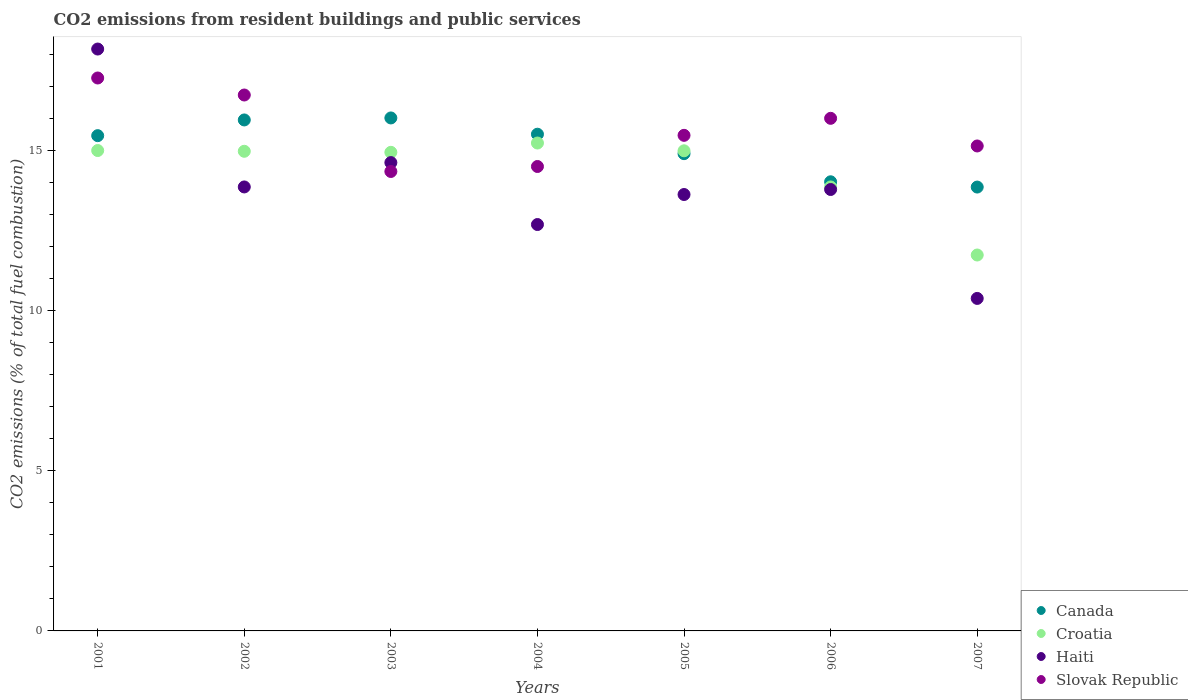Is the number of dotlines equal to the number of legend labels?
Your response must be concise. Yes. What is the total CO2 emitted in Canada in 2001?
Your answer should be very brief. 15.48. Across all years, what is the maximum total CO2 emitted in Slovak Republic?
Give a very brief answer. 17.28. Across all years, what is the minimum total CO2 emitted in Canada?
Your response must be concise. 13.87. In which year was the total CO2 emitted in Haiti minimum?
Ensure brevity in your answer.  2007. What is the total total CO2 emitted in Haiti in the graph?
Ensure brevity in your answer.  97.21. What is the difference between the total CO2 emitted in Canada in 2001 and that in 2005?
Your answer should be very brief. 0.56. What is the difference between the total CO2 emitted in Slovak Republic in 2002 and the total CO2 emitted in Haiti in 2005?
Your response must be concise. 3.11. What is the average total CO2 emitted in Haiti per year?
Offer a terse response. 13.89. In the year 2006, what is the difference between the total CO2 emitted in Haiti and total CO2 emitted in Croatia?
Provide a succinct answer. -0.08. What is the ratio of the total CO2 emitted in Haiti in 2004 to that in 2006?
Keep it short and to the point. 0.92. What is the difference between the highest and the second highest total CO2 emitted in Canada?
Give a very brief answer. 0.06. What is the difference between the highest and the lowest total CO2 emitted in Canada?
Ensure brevity in your answer.  2.16. In how many years, is the total CO2 emitted in Croatia greater than the average total CO2 emitted in Croatia taken over all years?
Your response must be concise. 5. Is the sum of the total CO2 emitted in Croatia in 2003 and 2006 greater than the maximum total CO2 emitted in Canada across all years?
Give a very brief answer. Yes. Does the total CO2 emitted in Croatia monotonically increase over the years?
Your response must be concise. No. Is the total CO2 emitted in Slovak Republic strictly less than the total CO2 emitted in Haiti over the years?
Ensure brevity in your answer.  No. How many years are there in the graph?
Keep it short and to the point. 7. What is the difference between two consecutive major ticks on the Y-axis?
Your answer should be very brief. 5. Are the values on the major ticks of Y-axis written in scientific E-notation?
Provide a succinct answer. No. Does the graph contain grids?
Offer a terse response. No. What is the title of the graph?
Provide a succinct answer. CO2 emissions from resident buildings and public services. What is the label or title of the X-axis?
Your answer should be very brief. Years. What is the label or title of the Y-axis?
Provide a short and direct response. CO2 emissions (% of total fuel combustion). What is the CO2 emissions (% of total fuel combustion) in Canada in 2001?
Keep it short and to the point. 15.48. What is the CO2 emissions (% of total fuel combustion) in Croatia in 2001?
Ensure brevity in your answer.  15.01. What is the CO2 emissions (% of total fuel combustion) of Haiti in 2001?
Make the answer very short. 18.18. What is the CO2 emissions (% of total fuel combustion) of Slovak Republic in 2001?
Your response must be concise. 17.28. What is the CO2 emissions (% of total fuel combustion) of Canada in 2002?
Give a very brief answer. 15.97. What is the CO2 emissions (% of total fuel combustion) of Croatia in 2002?
Make the answer very short. 14.99. What is the CO2 emissions (% of total fuel combustion) of Haiti in 2002?
Provide a succinct answer. 13.87. What is the CO2 emissions (% of total fuel combustion) in Slovak Republic in 2002?
Provide a succinct answer. 16.75. What is the CO2 emissions (% of total fuel combustion) of Canada in 2003?
Provide a succinct answer. 16.03. What is the CO2 emissions (% of total fuel combustion) in Croatia in 2003?
Your answer should be very brief. 14.95. What is the CO2 emissions (% of total fuel combustion) in Haiti in 2003?
Provide a succinct answer. 14.63. What is the CO2 emissions (% of total fuel combustion) in Slovak Republic in 2003?
Provide a short and direct response. 14.36. What is the CO2 emissions (% of total fuel combustion) in Canada in 2004?
Ensure brevity in your answer.  15.52. What is the CO2 emissions (% of total fuel combustion) of Croatia in 2004?
Make the answer very short. 15.25. What is the CO2 emissions (% of total fuel combustion) in Haiti in 2004?
Give a very brief answer. 12.7. What is the CO2 emissions (% of total fuel combustion) in Slovak Republic in 2004?
Ensure brevity in your answer.  14.51. What is the CO2 emissions (% of total fuel combustion) in Canada in 2005?
Make the answer very short. 14.91. What is the CO2 emissions (% of total fuel combustion) of Croatia in 2005?
Your response must be concise. 15. What is the CO2 emissions (% of total fuel combustion) in Haiti in 2005?
Your response must be concise. 13.64. What is the CO2 emissions (% of total fuel combustion) of Slovak Republic in 2005?
Your answer should be very brief. 15.49. What is the CO2 emissions (% of total fuel combustion) in Canada in 2006?
Your answer should be very brief. 14.03. What is the CO2 emissions (% of total fuel combustion) of Croatia in 2006?
Provide a succinct answer. 13.87. What is the CO2 emissions (% of total fuel combustion) in Haiti in 2006?
Provide a short and direct response. 13.79. What is the CO2 emissions (% of total fuel combustion) of Slovak Republic in 2006?
Offer a terse response. 16.02. What is the CO2 emissions (% of total fuel combustion) in Canada in 2007?
Offer a very short reply. 13.87. What is the CO2 emissions (% of total fuel combustion) in Croatia in 2007?
Make the answer very short. 11.75. What is the CO2 emissions (% of total fuel combustion) in Haiti in 2007?
Your response must be concise. 10.39. What is the CO2 emissions (% of total fuel combustion) of Slovak Republic in 2007?
Keep it short and to the point. 15.15. Across all years, what is the maximum CO2 emissions (% of total fuel combustion) of Canada?
Your response must be concise. 16.03. Across all years, what is the maximum CO2 emissions (% of total fuel combustion) of Croatia?
Your answer should be very brief. 15.25. Across all years, what is the maximum CO2 emissions (% of total fuel combustion) of Haiti?
Your response must be concise. 18.18. Across all years, what is the maximum CO2 emissions (% of total fuel combustion) in Slovak Republic?
Make the answer very short. 17.28. Across all years, what is the minimum CO2 emissions (% of total fuel combustion) in Canada?
Make the answer very short. 13.87. Across all years, what is the minimum CO2 emissions (% of total fuel combustion) of Croatia?
Ensure brevity in your answer.  11.75. Across all years, what is the minimum CO2 emissions (% of total fuel combustion) of Haiti?
Keep it short and to the point. 10.39. Across all years, what is the minimum CO2 emissions (% of total fuel combustion) of Slovak Republic?
Offer a very short reply. 14.36. What is the total CO2 emissions (% of total fuel combustion) in Canada in the graph?
Provide a succinct answer. 105.81. What is the total CO2 emissions (% of total fuel combustion) of Croatia in the graph?
Offer a terse response. 100.82. What is the total CO2 emissions (% of total fuel combustion) in Haiti in the graph?
Your answer should be compact. 97.21. What is the total CO2 emissions (% of total fuel combustion) in Slovak Republic in the graph?
Offer a very short reply. 109.55. What is the difference between the CO2 emissions (% of total fuel combustion) of Canada in 2001 and that in 2002?
Make the answer very short. -0.49. What is the difference between the CO2 emissions (% of total fuel combustion) in Croatia in 2001 and that in 2002?
Give a very brief answer. 0.02. What is the difference between the CO2 emissions (% of total fuel combustion) of Haiti in 2001 and that in 2002?
Keep it short and to the point. 4.31. What is the difference between the CO2 emissions (% of total fuel combustion) in Slovak Republic in 2001 and that in 2002?
Make the answer very short. 0.53. What is the difference between the CO2 emissions (% of total fuel combustion) in Canada in 2001 and that in 2003?
Offer a terse response. -0.55. What is the difference between the CO2 emissions (% of total fuel combustion) of Croatia in 2001 and that in 2003?
Ensure brevity in your answer.  0.06. What is the difference between the CO2 emissions (% of total fuel combustion) of Haiti in 2001 and that in 2003?
Provide a short and direct response. 3.55. What is the difference between the CO2 emissions (% of total fuel combustion) in Slovak Republic in 2001 and that in 2003?
Offer a terse response. 2.92. What is the difference between the CO2 emissions (% of total fuel combustion) in Canada in 2001 and that in 2004?
Provide a short and direct response. -0.05. What is the difference between the CO2 emissions (% of total fuel combustion) in Croatia in 2001 and that in 2004?
Offer a very short reply. -0.23. What is the difference between the CO2 emissions (% of total fuel combustion) in Haiti in 2001 and that in 2004?
Keep it short and to the point. 5.48. What is the difference between the CO2 emissions (% of total fuel combustion) in Slovak Republic in 2001 and that in 2004?
Keep it short and to the point. 2.77. What is the difference between the CO2 emissions (% of total fuel combustion) of Canada in 2001 and that in 2005?
Give a very brief answer. 0.56. What is the difference between the CO2 emissions (% of total fuel combustion) in Croatia in 2001 and that in 2005?
Your response must be concise. 0.01. What is the difference between the CO2 emissions (% of total fuel combustion) of Haiti in 2001 and that in 2005?
Your answer should be very brief. 4.55. What is the difference between the CO2 emissions (% of total fuel combustion) in Slovak Republic in 2001 and that in 2005?
Give a very brief answer. 1.79. What is the difference between the CO2 emissions (% of total fuel combustion) in Canada in 2001 and that in 2006?
Ensure brevity in your answer.  1.44. What is the difference between the CO2 emissions (% of total fuel combustion) of Croatia in 2001 and that in 2006?
Provide a succinct answer. 1.14. What is the difference between the CO2 emissions (% of total fuel combustion) in Haiti in 2001 and that in 2006?
Offer a terse response. 4.39. What is the difference between the CO2 emissions (% of total fuel combustion) of Slovak Republic in 2001 and that in 2006?
Ensure brevity in your answer.  1.26. What is the difference between the CO2 emissions (% of total fuel combustion) of Canada in 2001 and that in 2007?
Keep it short and to the point. 1.61. What is the difference between the CO2 emissions (% of total fuel combustion) in Croatia in 2001 and that in 2007?
Give a very brief answer. 3.26. What is the difference between the CO2 emissions (% of total fuel combustion) in Haiti in 2001 and that in 2007?
Ensure brevity in your answer.  7.79. What is the difference between the CO2 emissions (% of total fuel combustion) in Slovak Republic in 2001 and that in 2007?
Keep it short and to the point. 2.12. What is the difference between the CO2 emissions (% of total fuel combustion) of Canada in 2002 and that in 2003?
Provide a short and direct response. -0.06. What is the difference between the CO2 emissions (% of total fuel combustion) in Croatia in 2002 and that in 2003?
Your response must be concise. 0.03. What is the difference between the CO2 emissions (% of total fuel combustion) of Haiti in 2002 and that in 2003?
Provide a succinct answer. -0.76. What is the difference between the CO2 emissions (% of total fuel combustion) in Slovak Republic in 2002 and that in 2003?
Make the answer very short. 2.39. What is the difference between the CO2 emissions (% of total fuel combustion) in Canada in 2002 and that in 2004?
Your response must be concise. 0.45. What is the difference between the CO2 emissions (% of total fuel combustion) of Croatia in 2002 and that in 2004?
Offer a terse response. -0.26. What is the difference between the CO2 emissions (% of total fuel combustion) in Haiti in 2002 and that in 2004?
Your answer should be very brief. 1.17. What is the difference between the CO2 emissions (% of total fuel combustion) in Slovak Republic in 2002 and that in 2004?
Offer a very short reply. 2.23. What is the difference between the CO2 emissions (% of total fuel combustion) in Canada in 2002 and that in 2005?
Your answer should be compact. 1.05. What is the difference between the CO2 emissions (% of total fuel combustion) in Croatia in 2002 and that in 2005?
Offer a terse response. -0.02. What is the difference between the CO2 emissions (% of total fuel combustion) in Haiti in 2002 and that in 2005?
Give a very brief answer. 0.24. What is the difference between the CO2 emissions (% of total fuel combustion) in Slovak Republic in 2002 and that in 2005?
Make the answer very short. 1.26. What is the difference between the CO2 emissions (% of total fuel combustion) of Canada in 2002 and that in 2006?
Offer a very short reply. 1.93. What is the difference between the CO2 emissions (% of total fuel combustion) of Croatia in 2002 and that in 2006?
Your response must be concise. 1.11. What is the difference between the CO2 emissions (% of total fuel combustion) of Haiti in 2002 and that in 2006?
Offer a very short reply. 0.08. What is the difference between the CO2 emissions (% of total fuel combustion) in Slovak Republic in 2002 and that in 2006?
Your response must be concise. 0.73. What is the difference between the CO2 emissions (% of total fuel combustion) in Canada in 2002 and that in 2007?
Your response must be concise. 2.1. What is the difference between the CO2 emissions (% of total fuel combustion) in Croatia in 2002 and that in 2007?
Your response must be concise. 3.24. What is the difference between the CO2 emissions (% of total fuel combustion) of Haiti in 2002 and that in 2007?
Offer a very short reply. 3.48. What is the difference between the CO2 emissions (% of total fuel combustion) of Slovak Republic in 2002 and that in 2007?
Offer a terse response. 1.59. What is the difference between the CO2 emissions (% of total fuel combustion) in Canada in 2003 and that in 2004?
Ensure brevity in your answer.  0.51. What is the difference between the CO2 emissions (% of total fuel combustion) of Croatia in 2003 and that in 2004?
Offer a terse response. -0.29. What is the difference between the CO2 emissions (% of total fuel combustion) of Haiti in 2003 and that in 2004?
Your answer should be compact. 1.94. What is the difference between the CO2 emissions (% of total fuel combustion) in Slovak Republic in 2003 and that in 2004?
Your answer should be very brief. -0.16. What is the difference between the CO2 emissions (% of total fuel combustion) in Canada in 2003 and that in 2005?
Make the answer very short. 1.12. What is the difference between the CO2 emissions (% of total fuel combustion) in Croatia in 2003 and that in 2005?
Your answer should be compact. -0.05. What is the difference between the CO2 emissions (% of total fuel combustion) of Slovak Republic in 2003 and that in 2005?
Your answer should be compact. -1.13. What is the difference between the CO2 emissions (% of total fuel combustion) in Canada in 2003 and that in 2006?
Your answer should be compact. 1.99. What is the difference between the CO2 emissions (% of total fuel combustion) in Croatia in 2003 and that in 2006?
Your response must be concise. 1.08. What is the difference between the CO2 emissions (% of total fuel combustion) in Haiti in 2003 and that in 2006?
Provide a short and direct response. 0.84. What is the difference between the CO2 emissions (% of total fuel combustion) of Slovak Republic in 2003 and that in 2006?
Ensure brevity in your answer.  -1.66. What is the difference between the CO2 emissions (% of total fuel combustion) in Canada in 2003 and that in 2007?
Ensure brevity in your answer.  2.16. What is the difference between the CO2 emissions (% of total fuel combustion) in Croatia in 2003 and that in 2007?
Make the answer very short. 3.21. What is the difference between the CO2 emissions (% of total fuel combustion) of Haiti in 2003 and that in 2007?
Provide a succinct answer. 4.24. What is the difference between the CO2 emissions (% of total fuel combustion) of Slovak Republic in 2003 and that in 2007?
Offer a very short reply. -0.8. What is the difference between the CO2 emissions (% of total fuel combustion) in Canada in 2004 and that in 2005?
Offer a terse response. 0.61. What is the difference between the CO2 emissions (% of total fuel combustion) of Croatia in 2004 and that in 2005?
Your response must be concise. 0.24. What is the difference between the CO2 emissions (% of total fuel combustion) in Haiti in 2004 and that in 2005?
Make the answer very short. -0.94. What is the difference between the CO2 emissions (% of total fuel combustion) in Slovak Republic in 2004 and that in 2005?
Ensure brevity in your answer.  -0.97. What is the difference between the CO2 emissions (% of total fuel combustion) of Canada in 2004 and that in 2006?
Offer a very short reply. 1.49. What is the difference between the CO2 emissions (% of total fuel combustion) in Croatia in 2004 and that in 2006?
Your response must be concise. 1.37. What is the difference between the CO2 emissions (% of total fuel combustion) of Haiti in 2004 and that in 2006?
Offer a terse response. -1.09. What is the difference between the CO2 emissions (% of total fuel combustion) in Slovak Republic in 2004 and that in 2006?
Your response must be concise. -1.51. What is the difference between the CO2 emissions (% of total fuel combustion) in Canada in 2004 and that in 2007?
Give a very brief answer. 1.65. What is the difference between the CO2 emissions (% of total fuel combustion) of Croatia in 2004 and that in 2007?
Offer a terse response. 3.5. What is the difference between the CO2 emissions (% of total fuel combustion) of Haiti in 2004 and that in 2007?
Offer a terse response. 2.31. What is the difference between the CO2 emissions (% of total fuel combustion) in Slovak Republic in 2004 and that in 2007?
Provide a short and direct response. -0.64. What is the difference between the CO2 emissions (% of total fuel combustion) in Canada in 2005 and that in 2006?
Your response must be concise. 0.88. What is the difference between the CO2 emissions (% of total fuel combustion) of Croatia in 2005 and that in 2006?
Offer a very short reply. 1.13. What is the difference between the CO2 emissions (% of total fuel combustion) in Haiti in 2005 and that in 2006?
Keep it short and to the point. -0.16. What is the difference between the CO2 emissions (% of total fuel combustion) in Slovak Republic in 2005 and that in 2006?
Your answer should be compact. -0.53. What is the difference between the CO2 emissions (% of total fuel combustion) in Canada in 2005 and that in 2007?
Your answer should be compact. 1.04. What is the difference between the CO2 emissions (% of total fuel combustion) in Croatia in 2005 and that in 2007?
Give a very brief answer. 3.26. What is the difference between the CO2 emissions (% of total fuel combustion) in Haiti in 2005 and that in 2007?
Keep it short and to the point. 3.25. What is the difference between the CO2 emissions (% of total fuel combustion) in Slovak Republic in 2005 and that in 2007?
Make the answer very short. 0.33. What is the difference between the CO2 emissions (% of total fuel combustion) in Canada in 2006 and that in 2007?
Your response must be concise. 0.16. What is the difference between the CO2 emissions (% of total fuel combustion) in Croatia in 2006 and that in 2007?
Provide a succinct answer. 2.13. What is the difference between the CO2 emissions (% of total fuel combustion) of Haiti in 2006 and that in 2007?
Offer a terse response. 3.4. What is the difference between the CO2 emissions (% of total fuel combustion) in Slovak Republic in 2006 and that in 2007?
Provide a succinct answer. 0.86. What is the difference between the CO2 emissions (% of total fuel combustion) in Canada in 2001 and the CO2 emissions (% of total fuel combustion) in Croatia in 2002?
Give a very brief answer. 0.49. What is the difference between the CO2 emissions (% of total fuel combustion) in Canada in 2001 and the CO2 emissions (% of total fuel combustion) in Haiti in 2002?
Offer a terse response. 1.6. What is the difference between the CO2 emissions (% of total fuel combustion) of Canada in 2001 and the CO2 emissions (% of total fuel combustion) of Slovak Republic in 2002?
Provide a short and direct response. -1.27. What is the difference between the CO2 emissions (% of total fuel combustion) in Croatia in 2001 and the CO2 emissions (% of total fuel combustion) in Haiti in 2002?
Provide a succinct answer. 1.14. What is the difference between the CO2 emissions (% of total fuel combustion) of Croatia in 2001 and the CO2 emissions (% of total fuel combustion) of Slovak Republic in 2002?
Keep it short and to the point. -1.73. What is the difference between the CO2 emissions (% of total fuel combustion) of Haiti in 2001 and the CO2 emissions (% of total fuel combustion) of Slovak Republic in 2002?
Give a very brief answer. 1.44. What is the difference between the CO2 emissions (% of total fuel combustion) in Canada in 2001 and the CO2 emissions (% of total fuel combustion) in Croatia in 2003?
Make the answer very short. 0.52. What is the difference between the CO2 emissions (% of total fuel combustion) in Canada in 2001 and the CO2 emissions (% of total fuel combustion) in Haiti in 2003?
Ensure brevity in your answer.  0.84. What is the difference between the CO2 emissions (% of total fuel combustion) of Canada in 2001 and the CO2 emissions (% of total fuel combustion) of Slovak Republic in 2003?
Offer a very short reply. 1.12. What is the difference between the CO2 emissions (% of total fuel combustion) of Croatia in 2001 and the CO2 emissions (% of total fuel combustion) of Haiti in 2003?
Your answer should be very brief. 0.38. What is the difference between the CO2 emissions (% of total fuel combustion) of Croatia in 2001 and the CO2 emissions (% of total fuel combustion) of Slovak Republic in 2003?
Offer a very short reply. 0.65. What is the difference between the CO2 emissions (% of total fuel combustion) of Haiti in 2001 and the CO2 emissions (% of total fuel combustion) of Slovak Republic in 2003?
Keep it short and to the point. 3.83. What is the difference between the CO2 emissions (% of total fuel combustion) in Canada in 2001 and the CO2 emissions (% of total fuel combustion) in Croatia in 2004?
Keep it short and to the point. 0.23. What is the difference between the CO2 emissions (% of total fuel combustion) in Canada in 2001 and the CO2 emissions (% of total fuel combustion) in Haiti in 2004?
Provide a succinct answer. 2.78. What is the difference between the CO2 emissions (% of total fuel combustion) in Canada in 2001 and the CO2 emissions (% of total fuel combustion) in Slovak Republic in 2004?
Keep it short and to the point. 0.96. What is the difference between the CO2 emissions (% of total fuel combustion) in Croatia in 2001 and the CO2 emissions (% of total fuel combustion) in Haiti in 2004?
Provide a short and direct response. 2.31. What is the difference between the CO2 emissions (% of total fuel combustion) in Croatia in 2001 and the CO2 emissions (% of total fuel combustion) in Slovak Republic in 2004?
Make the answer very short. 0.5. What is the difference between the CO2 emissions (% of total fuel combustion) in Haiti in 2001 and the CO2 emissions (% of total fuel combustion) in Slovak Republic in 2004?
Make the answer very short. 3.67. What is the difference between the CO2 emissions (% of total fuel combustion) of Canada in 2001 and the CO2 emissions (% of total fuel combustion) of Croatia in 2005?
Provide a short and direct response. 0.47. What is the difference between the CO2 emissions (% of total fuel combustion) in Canada in 2001 and the CO2 emissions (% of total fuel combustion) in Haiti in 2005?
Provide a succinct answer. 1.84. What is the difference between the CO2 emissions (% of total fuel combustion) in Canada in 2001 and the CO2 emissions (% of total fuel combustion) in Slovak Republic in 2005?
Keep it short and to the point. -0.01. What is the difference between the CO2 emissions (% of total fuel combustion) in Croatia in 2001 and the CO2 emissions (% of total fuel combustion) in Haiti in 2005?
Offer a very short reply. 1.37. What is the difference between the CO2 emissions (% of total fuel combustion) of Croatia in 2001 and the CO2 emissions (% of total fuel combustion) of Slovak Republic in 2005?
Ensure brevity in your answer.  -0.47. What is the difference between the CO2 emissions (% of total fuel combustion) in Haiti in 2001 and the CO2 emissions (% of total fuel combustion) in Slovak Republic in 2005?
Keep it short and to the point. 2.7. What is the difference between the CO2 emissions (% of total fuel combustion) of Canada in 2001 and the CO2 emissions (% of total fuel combustion) of Croatia in 2006?
Ensure brevity in your answer.  1.6. What is the difference between the CO2 emissions (% of total fuel combustion) of Canada in 2001 and the CO2 emissions (% of total fuel combustion) of Haiti in 2006?
Ensure brevity in your answer.  1.68. What is the difference between the CO2 emissions (% of total fuel combustion) in Canada in 2001 and the CO2 emissions (% of total fuel combustion) in Slovak Republic in 2006?
Offer a terse response. -0.54. What is the difference between the CO2 emissions (% of total fuel combustion) of Croatia in 2001 and the CO2 emissions (% of total fuel combustion) of Haiti in 2006?
Provide a succinct answer. 1.22. What is the difference between the CO2 emissions (% of total fuel combustion) of Croatia in 2001 and the CO2 emissions (% of total fuel combustion) of Slovak Republic in 2006?
Your answer should be very brief. -1.01. What is the difference between the CO2 emissions (% of total fuel combustion) of Haiti in 2001 and the CO2 emissions (% of total fuel combustion) of Slovak Republic in 2006?
Give a very brief answer. 2.16. What is the difference between the CO2 emissions (% of total fuel combustion) of Canada in 2001 and the CO2 emissions (% of total fuel combustion) of Croatia in 2007?
Give a very brief answer. 3.73. What is the difference between the CO2 emissions (% of total fuel combustion) in Canada in 2001 and the CO2 emissions (% of total fuel combustion) in Haiti in 2007?
Keep it short and to the point. 5.09. What is the difference between the CO2 emissions (% of total fuel combustion) of Canada in 2001 and the CO2 emissions (% of total fuel combustion) of Slovak Republic in 2007?
Provide a succinct answer. 0.32. What is the difference between the CO2 emissions (% of total fuel combustion) in Croatia in 2001 and the CO2 emissions (% of total fuel combustion) in Haiti in 2007?
Ensure brevity in your answer.  4.62. What is the difference between the CO2 emissions (% of total fuel combustion) of Croatia in 2001 and the CO2 emissions (% of total fuel combustion) of Slovak Republic in 2007?
Your response must be concise. -0.14. What is the difference between the CO2 emissions (% of total fuel combustion) in Haiti in 2001 and the CO2 emissions (% of total fuel combustion) in Slovak Republic in 2007?
Provide a succinct answer. 3.03. What is the difference between the CO2 emissions (% of total fuel combustion) of Canada in 2002 and the CO2 emissions (% of total fuel combustion) of Croatia in 2003?
Offer a very short reply. 1.01. What is the difference between the CO2 emissions (% of total fuel combustion) in Canada in 2002 and the CO2 emissions (% of total fuel combustion) in Haiti in 2003?
Provide a succinct answer. 1.33. What is the difference between the CO2 emissions (% of total fuel combustion) in Canada in 2002 and the CO2 emissions (% of total fuel combustion) in Slovak Republic in 2003?
Offer a terse response. 1.61. What is the difference between the CO2 emissions (% of total fuel combustion) in Croatia in 2002 and the CO2 emissions (% of total fuel combustion) in Haiti in 2003?
Your response must be concise. 0.35. What is the difference between the CO2 emissions (% of total fuel combustion) in Croatia in 2002 and the CO2 emissions (% of total fuel combustion) in Slovak Republic in 2003?
Offer a very short reply. 0.63. What is the difference between the CO2 emissions (% of total fuel combustion) in Haiti in 2002 and the CO2 emissions (% of total fuel combustion) in Slovak Republic in 2003?
Keep it short and to the point. -0.48. What is the difference between the CO2 emissions (% of total fuel combustion) of Canada in 2002 and the CO2 emissions (% of total fuel combustion) of Croatia in 2004?
Your response must be concise. 0.72. What is the difference between the CO2 emissions (% of total fuel combustion) of Canada in 2002 and the CO2 emissions (% of total fuel combustion) of Haiti in 2004?
Your response must be concise. 3.27. What is the difference between the CO2 emissions (% of total fuel combustion) in Canada in 2002 and the CO2 emissions (% of total fuel combustion) in Slovak Republic in 2004?
Keep it short and to the point. 1.45. What is the difference between the CO2 emissions (% of total fuel combustion) of Croatia in 2002 and the CO2 emissions (% of total fuel combustion) of Haiti in 2004?
Keep it short and to the point. 2.29. What is the difference between the CO2 emissions (% of total fuel combustion) of Croatia in 2002 and the CO2 emissions (% of total fuel combustion) of Slovak Republic in 2004?
Give a very brief answer. 0.48. What is the difference between the CO2 emissions (% of total fuel combustion) in Haiti in 2002 and the CO2 emissions (% of total fuel combustion) in Slovak Republic in 2004?
Your answer should be very brief. -0.64. What is the difference between the CO2 emissions (% of total fuel combustion) in Canada in 2002 and the CO2 emissions (% of total fuel combustion) in Croatia in 2005?
Give a very brief answer. 0.96. What is the difference between the CO2 emissions (% of total fuel combustion) in Canada in 2002 and the CO2 emissions (% of total fuel combustion) in Haiti in 2005?
Offer a terse response. 2.33. What is the difference between the CO2 emissions (% of total fuel combustion) in Canada in 2002 and the CO2 emissions (% of total fuel combustion) in Slovak Republic in 2005?
Ensure brevity in your answer.  0.48. What is the difference between the CO2 emissions (% of total fuel combustion) of Croatia in 2002 and the CO2 emissions (% of total fuel combustion) of Haiti in 2005?
Offer a very short reply. 1.35. What is the difference between the CO2 emissions (% of total fuel combustion) of Croatia in 2002 and the CO2 emissions (% of total fuel combustion) of Slovak Republic in 2005?
Offer a terse response. -0.5. What is the difference between the CO2 emissions (% of total fuel combustion) of Haiti in 2002 and the CO2 emissions (% of total fuel combustion) of Slovak Republic in 2005?
Make the answer very short. -1.61. What is the difference between the CO2 emissions (% of total fuel combustion) in Canada in 2002 and the CO2 emissions (% of total fuel combustion) in Croatia in 2006?
Ensure brevity in your answer.  2.09. What is the difference between the CO2 emissions (% of total fuel combustion) of Canada in 2002 and the CO2 emissions (% of total fuel combustion) of Haiti in 2006?
Provide a succinct answer. 2.17. What is the difference between the CO2 emissions (% of total fuel combustion) of Canada in 2002 and the CO2 emissions (% of total fuel combustion) of Slovak Republic in 2006?
Offer a terse response. -0.05. What is the difference between the CO2 emissions (% of total fuel combustion) of Croatia in 2002 and the CO2 emissions (% of total fuel combustion) of Haiti in 2006?
Your response must be concise. 1.19. What is the difference between the CO2 emissions (% of total fuel combustion) in Croatia in 2002 and the CO2 emissions (% of total fuel combustion) in Slovak Republic in 2006?
Offer a terse response. -1.03. What is the difference between the CO2 emissions (% of total fuel combustion) in Haiti in 2002 and the CO2 emissions (% of total fuel combustion) in Slovak Republic in 2006?
Ensure brevity in your answer.  -2.14. What is the difference between the CO2 emissions (% of total fuel combustion) in Canada in 2002 and the CO2 emissions (% of total fuel combustion) in Croatia in 2007?
Give a very brief answer. 4.22. What is the difference between the CO2 emissions (% of total fuel combustion) of Canada in 2002 and the CO2 emissions (% of total fuel combustion) of Haiti in 2007?
Provide a succinct answer. 5.58. What is the difference between the CO2 emissions (% of total fuel combustion) in Canada in 2002 and the CO2 emissions (% of total fuel combustion) in Slovak Republic in 2007?
Your answer should be compact. 0.81. What is the difference between the CO2 emissions (% of total fuel combustion) of Croatia in 2002 and the CO2 emissions (% of total fuel combustion) of Haiti in 2007?
Your answer should be very brief. 4.6. What is the difference between the CO2 emissions (% of total fuel combustion) of Croatia in 2002 and the CO2 emissions (% of total fuel combustion) of Slovak Republic in 2007?
Ensure brevity in your answer.  -0.17. What is the difference between the CO2 emissions (% of total fuel combustion) of Haiti in 2002 and the CO2 emissions (% of total fuel combustion) of Slovak Republic in 2007?
Ensure brevity in your answer.  -1.28. What is the difference between the CO2 emissions (% of total fuel combustion) of Canada in 2003 and the CO2 emissions (% of total fuel combustion) of Croatia in 2004?
Keep it short and to the point. 0.78. What is the difference between the CO2 emissions (% of total fuel combustion) in Canada in 2003 and the CO2 emissions (% of total fuel combustion) in Haiti in 2004?
Your answer should be very brief. 3.33. What is the difference between the CO2 emissions (% of total fuel combustion) in Canada in 2003 and the CO2 emissions (% of total fuel combustion) in Slovak Republic in 2004?
Your answer should be compact. 1.52. What is the difference between the CO2 emissions (% of total fuel combustion) in Croatia in 2003 and the CO2 emissions (% of total fuel combustion) in Haiti in 2004?
Your response must be concise. 2.26. What is the difference between the CO2 emissions (% of total fuel combustion) in Croatia in 2003 and the CO2 emissions (% of total fuel combustion) in Slovak Republic in 2004?
Ensure brevity in your answer.  0.44. What is the difference between the CO2 emissions (% of total fuel combustion) in Haiti in 2003 and the CO2 emissions (% of total fuel combustion) in Slovak Republic in 2004?
Give a very brief answer. 0.12. What is the difference between the CO2 emissions (% of total fuel combustion) of Canada in 2003 and the CO2 emissions (% of total fuel combustion) of Croatia in 2005?
Provide a succinct answer. 1.03. What is the difference between the CO2 emissions (% of total fuel combustion) in Canada in 2003 and the CO2 emissions (% of total fuel combustion) in Haiti in 2005?
Provide a succinct answer. 2.39. What is the difference between the CO2 emissions (% of total fuel combustion) in Canada in 2003 and the CO2 emissions (% of total fuel combustion) in Slovak Republic in 2005?
Make the answer very short. 0.54. What is the difference between the CO2 emissions (% of total fuel combustion) of Croatia in 2003 and the CO2 emissions (% of total fuel combustion) of Haiti in 2005?
Offer a very short reply. 1.32. What is the difference between the CO2 emissions (% of total fuel combustion) of Croatia in 2003 and the CO2 emissions (% of total fuel combustion) of Slovak Republic in 2005?
Keep it short and to the point. -0.53. What is the difference between the CO2 emissions (% of total fuel combustion) in Haiti in 2003 and the CO2 emissions (% of total fuel combustion) in Slovak Republic in 2005?
Ensure brevity in your answer.  -0.85. What is the difference between the CO2 emissions (% of total fuel combustion) of Canada in 2003 and the CO2 emissions (% of total fuel combustion) of Croatia in 2006?
Keep it short and to the point. 2.16. What is the difference between the CO2 emissions (% of total fuel combustion) in Canada in 2003 and the CO2 emissions (% of total fuel combustion) in Haiti in 2006?
Make the answer very short. 2.24. What is the difference between the CO2 emissions (% of total fuel combustion) of Canada in 2003 and the CO2 emissions (% of total fuel combustion) of Slovak Republic in 2006?
Provide a succinct answer. 0.01. What is the difference between the CO2 emissions (% of total fuel combustion) of Croatia in 2003 and the CO2 emissions (% of total fuel combustion) of Haiti in 2006?
Make the answer very short. 1.16. What is the difference between the CO2 emissions (% of total fuel combustion) in Croatia in 2003 and the CO2 emissions (% of total fuel combustion) in Slovak Republic in 2006?
Ensure brevity in your answer.  -1.06. What is the difference between the CO2 emissions (% of total fuel combustion) in Haiti in 2003 and the CO2 emissions (% of total fuel combustion) in Slovak Republic in 2006?
Keep it short and to the point. -1.38. What is the difference between the CO2 emissions (% of total fuel combustion) of Canada in 2003 and the CO2 emissions (% of total fuel combustion) of Croatia in 2007?
Keep it short and to the point. 4.28. What is the difference between the CO2 emissions (% of total fuel combustion) in Canada in 2003 and the CO2 emissions (% of total fuel combustion) in Haiti in 2007?
Your response must be concise. 5.64. What is the difference between the CO2 emissions (% of total fuel combustion) of Canada in 2003 and the CO2 emissions (% of total fuel combustion) of Slovak Republic in 2007?
Your response must be concise. 0.88. What is the difference between the CO2 emissions (% of total fuel combustion) of Croatia in 2003 and the CO2 emissions (% of total fuel combustion) of Haiti in 2007?
Make the answer very short. 4.57. What is the difference between the CO2 emissions (% of total fuel combustion) in Croatia in 2003 and the CO2 emissions (% of total fuel combustion) in Slovak Republic in 2007?
Ensure brevity in your answer.  -0.2. What is the difference between the CO2 emissions (% of total fuel combustion) in Haiti in 2003 and the CO2 emissions (% of total fuel combustion) in Slovak Republic in 2007?
Offer a very short reply. -0.52. What is the difference between the CO2 emissions (% of total fuel combustion) in Canada in 2004 and the CO2 emissions (% of total fuel combustion) in Croatia in 2005?
Your response must be concise. 0.52. What is the difference between the CO2 emissions (% of total fuel combustion) of Canada in 2004 and the CO2 emissions (% of total fuel combustion) of Haiti in 2005?
Provide a short and direct response. 1.88. What is the difference between the CO2 emissions (% of total fuel combustion) of Canada in 2004 and the CO2 emissions (% of total fuel combustion) of Slovak Republic in 2005?
Offer a very short reply. 0.04. What is the difference between the CO2 emissions (% of total fuel combustion) in Croatia in 2004 and the CO2 emissions (% of total fuel combustion) in Haiti in 2005?
Your answer should be compact. 1.61. What is the difference between the CO2 emissions (% of total fuel combustion) of Croatia in 2004 and the CO2 emissions (% of total fuel combustion) of Slovak Republic in 2005?
Your response must be concise. -0.24. What is the difference between the CO2 emissions (% of total fuel combustion) of Haiti in 2004 and the CO2 emissions (% of total fuel combustion) of Slovak Republic in 2005?
Keep it short and to the point. -2.79. What is the difference between the CO2 emissions (% of total fuel combustion) of Canada in 2004 and the CO2 emissions (% of total fuel combustion) of Croatia in 2006?
Give a very brief answer. 1.65. What is the difference between the CO2 emissions (% of total fuel combustion) of Canada in 2004 and the CO2 emissions (% of total fuel combustion) of Haiti in 2006?
Keep it short and to the point. 1.73. What is the difference between the CO2 emissions (% of total fuel combustion) of Canada in 2004 and the CO2 emissions (% of total fuel combustion) of Slovak Republic in 2006?
Make the answer very short. -0.5. What is the difference between the CO2 emissions (% of total fuel combustion) of Croatia in 2004 and the CO2 emissions (% of total fuel combustion) of Haiti in 2006?
Make the answer very short. 1.45. What is the difference between the CO2 emissions (% of total fuel combustion) in Croatia in 2004 and the CO2 emissions (% of total fuel combustion) in Slovak Republic in 2006?
Provide a succinct answer. -0.77. What is the difference between the CO2 emissions (% of total fuel combustion) of Haiti in 2004 and the CO2 emissions (% of total fuel combustion) of Slovak Republic in 2006?
Offer a terse response. -3.32. What is the difference between the CO2 emissions (% of total fuel combustion) in Canada in 2004 and the CO2 emissions (% of total fuel combustion) in Croatia in 2007?
Provide a succinct answer. 3.77. What is the difference between the CO2 emissions (% of total fuel combustion) of Canada in 2004 and the CO2 emissions (% of total fuel combustion) of Haiti in 2007?
Ensure brevity in your answer.  5.13. What is the difference between the CO2 emissions (% of total fuel combustion) in Canada in 2004 and the CO2 emissions (% of total fuel combustion) in Slovak Republic in 2007?
Give a very brief answer. 0.37. What is the difference between the CO2 emissions (% of total fuel combustion) in Croatia in 2004 and the CO2 emissions (% of total fuel combustion) in Haiti in 2007?
Offer a very short reply. 4.86. What is the difference between the CO2 emissions (% of total fuel combustion) in Croatia in 2004 and the CO2 emissions (% of total fuel combustion) in Slovak Republic in 2007?
Provide a short and direct response. 0.09. What is the difference between the CO2 emissions (% of total fuel combustion) of Haiti in 2004 and the CO2 emissions (% of total fuel combustion) of Slovak Republic in 2007?
Provide a short and direct response. -2.45. What is the difference between the CO2 emissions (% of total fuel combustion) of Canada in 2005 and the CO2 emissions (% of total fuel combustion) of Croatia in 2006?
Ensure brevity in your answer.  1.04. What is the difference between the CO2 emissions (% of total fuel combustion) in Canada in 2005 and the CO2 emissions (% of total fuel combustion) in Haiti in 2006?
Your answer should be very brief. 1.12. What is the difference between the CO2 emissions (% of total fuel combustion) of Canada in 2005 and the CO2 emissions (% of total fuel combustion) of Slovak Republic in 2006?
Provide a succinct answer. -1.1. What is the difference between the CO2 emissions (% of total fuel combustion) in Croatia in 2005 and the CO2 emissions (% of total fuel combustion) in Haiti in 2006?
Provide a short and direct response. 1.21. What is the difference between the CO2 emissions (% of total fuel combustion) in Croatia in 2005 and the CO2 emissions (% of total fuel combustion) in Slovak Republic in 2006?
Offer a very short reply. -1.01. What is the difference between the CO2 emissions (% of total fuel combustion) in Haiti in 2005 and the CO2 emissions (% of total fuel combustion) in Slovak Republic in 2006?
Offer a very short reply. -2.38. What is the difference between the CO2 emissions (% of total fuel combustion) of Canada in 2005 and the CO2 emissions (% of total fuel combustion) of Croatia in 2007?
Your answer should be compact. 3.17. What is the difference between the CO2 emissions (% of total fuel combustion) of Canada in 2005 and the CO2 emissions (% of total fuel combustion) of Haiti in 2007?
Provide a short and direct response. 4.52. What is the difference between the CO2 emissions (% of total fuel combustion) of Canada in 2005 and the CO2 emissions (% of total fuel combustion) of Slovak Republic in 2007?
Make the answer very short. -0.24. What is the difference between the CO2 emissions (% of total fuel combustion) in Croatia in 2005 and the CO2 emissions (% of total fuel combustion) in Haiti in 2007?
Ensure brevity in your answer.  4.61. What is the difference between the CO2 emissions (% of total fuel combustion) in Croatia in 2005 and the CO2 emissions (% of total fuel combustion) in Slovak Republic in 2007?
Keep it short and to the point. -0.15. What is the difference between the CO2 emissions (% of total fuel combustion) of Haiti in 2005 and the CO2 emissions (% of total fuel combustion) of Slovak Republic in 2007?
Keep it short and to the point. -1.52. What is the difference between the CO2 emissions (% of total fuel combustion) in Canada in 2006 and the CO2 emissions (% of total fuel combustion) in Croatia in 2007?
Make the answer very short. 2.29. What is the difference between the CO2 emissions (% of total fuel combustion) in Canada in 2006 and the CO2 emissions (% of total fuel combustion) in Haiti in 2007?
Provide a short and direct response. 3.64. What is the difference between the CO2 emissions (% of total fuel combustion) of Canada in 2006 and the CO2 emissions (% of total fuel combustion) of Slovak Republic in 2007?
Provide a short and direct response. -1.12. What is the difference between the CO2 emissions (% of total fuel combustion) in Croatia in 2006 and the CO2 emissions (% of total fuel combustion) in Haiti in 2007?
Give a very brief answer. 3.48. What is the difference between the CO2 emissions (% of total fuel combustion) of Croatia in 2006 and the CO2 emissions (% of total fuel combustion) of Slovak Republic in 2007?
Offer a very short reply. -1.28. What is the difference between the CO2 emissions (% of total fuel combustion) in Haiti in 2006 and the CO2 emissions (% of total fuel combustion) in Slovak Republic in 2007?
Your answer should be very brief. -1.36. What is the average CO2 emissions (% of total fuel combustion) of Canada per year?
Ensure brevity in your answer.  15.12. What is the average CO2 emissions (% of total fuel combustion) of Croatia per year?
Provide a succinct answer. 14.4. What is the average CO2 emissions (% of total fuel combustion) of Haiti per year?
Keep it short and to the point. 13.89. What is the average CO2 emissions (% of total fuel combustion) in Slovak Republic per year?
Offer a very short reply. 15.65. In the year 2001, what is the difference between the CO2 emissions (% of total fuel combustion) in Canada and CO2 emissions (% of total fuel combustion) in Croatia?
Offer a very short reply. 0.46. In the year 2001, what is the difference between the CO2 emissions (% of total fuel combustion) in Canada and CO2 emissions (% of total fuel combustion) in Haiti?
Make the answer very short. -2.71. In the year 2001, what is the difference between the CO2 emissions (% of total fuel combustion) of Canada and CO2 emissions (% of total fuel combustion) of Slovak Republic?
Give a very brief answer. -1.8. In the year 2001, what is the difference between the CO2 emissions (% of total fuel combustion) in Croatia and CO2 emissions (% of total fuel combustion) in Haiti?
Ensure brevity in your answer.  -3.17. In the year 2001, what is the difference between the CO2 emissions (% of total fuel combustion) of Croatia and CO2 emissions (% of total fuel combustion) of Slovak Republic?
Ensure brevity in your answer.  -2.27. In the year 2001, what is the difference between the CO2 emissions (% of total fuel combustion) of Haiti and CO2 emissions (% of total fuel combustion) of Slovak Republic?
Your answer should be compact. 0.9. In the year 2002, what is the difference between the CO2 emissions (% of total fuel combustion) of Canada and CO2 emissions (% of total fuel combustion) of Croatia?
Your answer should be compact. 0.98. In the year 2002, what is the difference between the CO2 emissions (% of total fuel combustion) in Canada and CO2 emissions (% of total fuel combustion) in Haiti?
Provide a short and direct response. 2.09. In the year 2002, what is the difference between the CO2 emissions (% of total fuel combustion) of Canada and CO2 emissions (% of total fuel combustion) of Slovak Republic?
Offer a very short reply. -0.78. In the year 2002, what is the difference between the CO2 emissions (% of total fuel combustion) of Croatia and CO2 emissions (% of total fuel combustion) of Haiti?
Provide a short and direct response. 1.11. In the year 2002, what is the difference between the CO2 emissions (% of total fuel combustion) of Croatia and CO2 emissions (% of total fuel combustion) of Slovak Republic?
Your answer should be compact. -1.76. In the year 2002, what is the difference between the CO2 emissions (% of total fuel combustion) of Haiti and CO2 emissions (% of total fuel combustion) of Slovak Republic?
Your response must be concise. -2.87. In the year 2003, what is the difference between the CO2 emissions (% of total fuel combustion) in Canada and CO2 emissions (% of total fuel combustion) in Croatia?
Give a very brief answer. 1.07. In the year 2003, what is the difference between the CO2 emissions (% of total fuel combustion) of Canada and CO2 emissions (% of total fuel combustion) of Haiti?
Ensure brevity in your answer.  1.39. In the year 2003, what is the difference between the CO2 emissions (% of total fuel combustion) of Canada and CO2 emissions (% of total fuel combustion) of Slovak Republic?
Offer a terse response. 1.67. In the year 2003, what is the difference between the CO2 emissions (% of total fuel combustion) in Croatia and CO2 emissions (% of total fuel combustion) in Haiti?
Provide a short and direct response. 0.32. In the year 2003, what is the difference between the CO2 emissions (% of total fuel combustion) in Croatia and CO2 emissions (% of total fuel combustion) in Slovak Republic?
Offer a very short reply. 0.6. In the year 2003, what is the difference between the CO2 emissions (% of total fuel combustion) in Haiti and CO2 emissions (% of total fuel combustion) in Slovak Republic?
Your answer should be very brief. 0.28. In the year 2004, what is the difference between the CO2 emissions (% of total fuel combustion) of Canada and CO2 emissions (% of total fuel combustion) of Croatia?
Provide a succinct answer. 0.28. In the year 2004, what is the difference between the CO2 emissions (% of total fuel combustion) of Canada and CO2 emissions (% of total fuel combustion) of Haiti?
Provide a succinct answer. 2.82. In the year 2004, what is the difference between the CO2 emissions (% of total fuel combustion) in Canada and CO2 emissions (% of total fuel combustion) in Slovak Republic?
Your response must be concise. 1.01. In the year 2004, what is the difference between the CO2 emissions (% of total fuel combustion) of Croatia and CO2 emissions (% of total fuel combustion) of Haiti?
Provide a succinct answer. 2.55. In the year 2004, what is the difference between the CO2 emissions (% of total fuel combustion) in Croatia and CO2 emissions (% of total fuel combustion) in Slovak Republic?
Provide a succinct answer. 0.73. In the year 2004, what is the difference between the CO2 emissions (% of total fuel combustion) of Haiti and CO2 emissions (% of total fuel combustion) of Slovak Republic?
Your answer should be compact. -1.81. In the year 2005, what is the difference between the CO2 emissions (% of total fuel combustion) of Canada and CO2 emissions (% of total fuel combustion) of Croatia?
Your answer should be compact. -0.09. In the year 2005, what is the difference between the CO2 emissions (% of total fuel combustion) of Canada and CO2 emissions (% of total fuel combustion) of Haiti?
Your answer should be very brief. 1.28. In the year 2005, what is the difference between the CO2 emissions (% of total fuel combustion) in Canada and CO2 emissions (% of total fuel combustion) in Slovak Republic?
Offer a terse response. -0.57. In the year 2005, what is the difference between the CO2 emissions (% of total fuel combustion) in Croatia and CO2 emissions (% of total fuel combustion) in Haiti?
Offer a very short reply. 1.37. In the year 2005, what is the difference between the CO2 emissions (% of total fuel combustion) of Croatia and CO2 emissions (% of total fuel combustion) of Slovak Republic?
Your response must be concise. -0.48. In the year 2005, what is the difference between the CO2 emissions (% of total fuel combustion) of Haiti and CO2 emissions (% of total fuel combustion) of Slovak Republic?
Keep it short and to the point. -1.85. In the year 2006, what is the difference between the CO2 emissions (% of total fuel combustion) in Canada and CO2 emissions (% of total fuel combustion) in Croatia?
Provide a succinct answer. 0.16. In the year 2006, what is the difference between the CO2 emissions (% of total fuel combustion) in Canada and CO2 emissions (% of total fuel combustion) in Haiti?
Provide a succinct answer. 0.24. In the year 2006, what is the difference between the CO2 emissions (% of total fuel combustion) of Canada and CO2 emissions (% of total fuel combustion) of Slovak Republic?
Ensure brevity in your answer.  -1.98. In the year 2006, what is the difference between the CO2 emissions (% of total fuel combustion) in Croatia and CO2 emissions (% of total fuel combustion) in Haiti?
Keep it short and to the point. 0.08. In the year 2006, what is the difference between the CO2 emissions (% of total fuel combustion) in Croatia and CO2 emissions (% of total fuel combustion) in Slovak Republic?
Ensure brevity in your answer.  -2.14. In the year 2006, what is the difference between the CO2 emissions (% of total fuel combustion) of Haiti and CO2 emissions (% of total fuel combustion) of Slovak Republic?
Ensure brevity in your answer.  -2.22. In the year 2007, what is the difference between the CO2 emissions (% of total fuel combustion) of Canada and CO2 emissions (% of total fuel combustion) of Croatia?
Offer a very short reply. 2.12. In the year 2007, what is the difference between the CO2 emissions (% of total fuel combustion) in Canada and CO2 emissions (% of total fuel combustion) in Haiti?
Your answer should be very brief. 3.48. In the year 2007, what is the difference between the CO2 emissions (% of total fuel combustion) in Canada and CO2 emissions (% of total fuel combustion) in Slovak Republic?
Provide a short and direct response. -1.28. In the year 2007, what is the difference between the CO2 emissions (% of total fuel combustion) in Croatia and CO2 emissions (% of total fuel combustion) in Haiti?
Your response must be concise. 1.36. In the year 2007, what is the difference between the CO2 emissions (% of total fuel combustion) in Croatia and CO2 emissions (% of total fuel combustion) in Slovak Republic?
Make the answer very short. -3.41. In the year 2007, what is the difference between the CO2 emissions (% of total fuel combustion) of Haiti and CO2 emissions (% of total fuel combustion) of Slovak Republic?
Your answer should be compact. -4.76. What is the ratio of the CO2 emissions (% of total fuel combustion) in Canada in 2001 to that in 2002?
Offer a terse response. 0.97. What is the ratio of the CO2 emissions (% of total fuel combustion) in Croatia in 2001 to that in 2002?
Offer a terse response. 1. What is the ratio of the CO2 emissions (% of total fuel combustion) of Haiti in 2001 to that in 2002?
Your answer should be very brief. 1.31. What is the ratio of the CO2 emissions (% of total fuel combustion) of Slovak Republic in 2001 to that in 2002?
Your answer should be very brief. 1.03. What is the ratio of the CO2 emissions (% of total fuel combustion) in Canada in 2001 to that in 2003?
Make the answer very short. 0.97. What is the ratio of the CO2 emissions (% of total fuel combustion) of Croatia in 2001 to that in 2003?
Make the answer very short. 1. What is the ratio of the CO2 emissions (% of total fuel combustion) of Haiti in 2001 to that in 2003?
Your answer should be compact. 1.24. What is the ratio of the CO2 emissions (% of total fuel combustion) of Slovak Republic in 2001 to that in 2003?
Offer a terse response. 1.2. What is the ratio of the CO2 emissions (% of total fuel combustion) in Canada in 2001 to that in 2004?
Your response must be concise. 1. What is the ratio of the CO2 emissions (% of total fuel combustion) of Croatia in 2001 to that in 2004?
Your response must be concise. 0.98. What is the ratio of the CO2 emissions (% of total fuel combustion) in Haiti in 2001 to that in 2004?
Offer a very short reply. 1.43. What is the ratio of the CO2 emissions (% of total fuel combustion) of Slovak Republic in 2001 to that in 2004?
Give a very brief answer. 1.19. What is the ratio of the CO2 emissions (% of total fuel combustion) in Canada in 2001 to that in 2005?
Ensure brevity in your answer.  1.04. What is the ratio of the CO2 emissions (% of total fuel combustion) in Slovak Republic in 2001 to that in 2005?
Ensure brevity in your answer.  1.12. What is the ratio of the CO2 emissions (% of total fuel combustion) of Canada in 2001 to that in 2006?
Make the answer very short. 1.1. What is the ratio of the CO2 emissions (% of total fuel combustion) of Croatia in 2001 to that in 2006?
Provide a succinct answer. 1.08. What is the ratio of the CO2 emissions (% of total fuel combustion) of Haiti in 2001 to that in 2006?
Your answer should be very brief. 1.32. What is the ratio of the CO2 emissions (% of total fuel combustion) in Slovak Republic in 2001 to that in 2006?
Make the answer very short. 1.08. What is the ratio of the CO2 emissions (% of total fuel combustion) of Canada in 2001 to that in 2007?
Your answer should be compact. 1.12. What is the ratio of the CO2 emissions (% of total fuel combustion) in Croatia in 2001 to that in 2007?
Provide a succinct answer. 1.28. What is the ratio of the CO2 emissions (% of total fuel combustion) in Slovak Republic in 2001 to that in 2007?
Offer a terse response. 1.14. What is the ratio of the CO2 emissions (% of total fuel combustion) of Canada in 2002 to that in 2003?
Your response must be concise. 1. What is the ratio of the CO2 emissions (% of total fuel combustion) in Haiti in 2002 to that in 2003?
Make the answer very short. 0.95. What is the ratio of the CO2 emissions (% of total fuel combustion) of Slovak Republic in 2002 to that in 2003?
Your answer should be compact. 1.17. What is the ratio of the CO2 emissions (% of total fuel combustion) in Canada in 2002 to that in 2004?
Offer a very short reply. 1.03. What is the ratio of the CO2 emissions (% of total fuel combustion) in Croatia in 2002 to that in 2004?
Offer a very short reply. 0.98. What is the ratio of the CO2 emissions (% of total fuel combustion) in Haiti in 2002 to that in 2004?
Give a very brief answer. 1.09. What is the ratio of the CO2 emissions (% of total fuel combustion) of Slovak Republic in 2002 to that in 2004?
Keep it short and to the point. 1.15. What is the ratio of the CO2 emissions (% of total fuel combustion) of Canada in 2002 to that in 2005?
Ensure brevity in your answer.  1.07. What is the ratio of the CO2 emissions (% of total fuel combustion) of Haiti in 2002 to that in 2005?
Provide a succinct answer. 1.02. What is the ratio of the CO2 emissions (% of total fuel combustion) of Slovak Republic in 2002 to that in 2005?
Offer a very short reply. 1.08. What is the ratio of the CO2 emissions (% of total fuel combustion) of Canada in 2002 to that in 2006?
Your response must be concise. 1.14. What is the ratio of the CO2 emissions (% of total fuel combustion) of Croatia in 2002 to that in 2006?
Your response must be concise. 1.08. What is the ratio of the CO2 emissions (% of total fuel combustion) of Haiti in 2002 to that in 2006?
Offer a terse response. 1.01. What is the ratio of the CO2 emissions (% of total fuel combustion) in Slovak Republic in 2002 to that in 2006?
Your answer should be compact. 1.05. What is the ratio of the CO2 emissions (% of total fuel combustion) in Canada in 2002 to that in 2007?
Keep it short and to the point. 1.15. What is the ratio of the CO2 emissions (% of total fuel combustion) in Croatia in 2002 to that in 2007?
Make the answer very short. 1.28. What is the ratio of the CO2 emissions (% of total fuel combustion) in Haiti in 2002 to that in 2007?
Your answer should be very brief. 1.34. What is the ratio of the CO2 emissions (% of total fuel combustion) of Slovak Republic in 2002 to that in 2007?
Keep it short and to the point. 1.11. What is the ratio of the CO2 emissions (% of total fuel combustion) of Canada in 2003 to that in 2004?
Give a very brief answer. 1.03. What is the ratio of the CO2 emissions (% of total fuel combustion) in Croatia in 2003 to that in 2004?
Provide a succinct answer. 0.98. What is the ratio of the CO2 emissions (% of total fuel combustion) of Haiti in 2003 to that in 2004?
Your answer should be very brief. 1.15. What is the ratio of the CO2 emissions (% of total fuel combustion) in Slovak Republic in 2003 to that in 2004?
Offer a terse response. 0.99. What is the ratio of the CO2 emissions (% of total fuel combustion) in Canada in 2003 to that in 2005?
Make the answer very short. 1.07. What is the ratio of the CO2 emissions (% of total fuel combustion) of Haiti in 2003 to that in 2005?
Provide a succinct answer. 1.07. What is the ratio of the CO2 emissions (% of total fuel combustion) in Slovak Republic in 2003 to that in 2005?
Offer a very short reply. 0.93. What is the ratio of the CO2 emissions (% of total fuel combustion) of Canada in 2003 to that in 2006?
Give a very brief answer. 1.14. What is the ratio of the CO2 emissions (% of total fuel combustion) of Croatia in 2003 to that in 2006?
Ensure brevity in your answer.  1.08. What is the ratio of the CO2 emissions (% of total fuel combustion) of Haiti in 2003 to that in 2006?
Give a very brief answer. 1.06. What is the ratio of the CO2 emissions (% of total fuel combustion) of Slovak Republic in 2003 to that in 2006?
Your response must be concise. 0.9. What is the ratio of the CO2 emissions (% of total fuel combustion) of Canada in 2003 to that in 2007?
Offer a very short reply. 1.16. What is the ratio of the CO2 emissions (% of total fuel combustion) of Croatia in 2003 to that in 2007?
Your response must be concise. 1.27. What is the ratio of the CO2 emissions (% of total fuel combustion) in Haiti in 2003 to that in 2007?
Provide a short and direct response. 1.41. What is the ratio of the CO2 emissions (% of total fuel combustion) of Slovak Republic in 2003 to that in 2007?
Make the answer very short. 0.95. What is the ratio of the CO2 emissions (% of total fuel combustion) in Canada in 2004 to that in 2005?
Give a very brief answer. 1.04. What is the ratio of the CO2 emissions (% of total fuel combustion) of Croatia in 2004 to that in 2005?
Your response must be concise. 1.02. What is the ratio of the CO2 emissions (% of total fuel combustion) of Haiti in 2004 to that in 2005?
Offer a very short reply. 0.93. What is the ratio of the CO2 emissions (% of total fuel combustion) of Slovak Republic in 2004 to that in 2005?
Provide a succinct answer. 0.94. What is the ratio of the CO2 emissions (% of total fuel combustion) of Canada in 2004 to that in 2006?
Provide a short and direct response. 1.11. What is the ratio of the CO2 emissions (% of total fuel combustion) of Croatia in 2004 to that in 2006?
Make the answer very short. 1.1. What is the ratio of the CO2 emissions (% of total fuel combustion) in Haiti in 2004 to that in 2006?
Provide a short and direct response. 0.92. What is the ratio of the CO2 emissions (% of total fuel combustion) in Slovak Republic in 2004 to that in 2006?
Provide a succinct answer. 0.91. What is the ratio of the CO2 emissions (% of total fuel combustion) in Canada in 2004 to that in 2007?
Keep it short and to the point. 1.12. What is the ratio of the CO2 emissions (% of total fuel combustion) of Croatia in 2004 to that in 2007?
Make the answer very short. 1.3. What is the ratio of the CO2 emissions (% of total fuel combustion) of Haiti in 2004 to that in 2007?
Keep it short and to the point. 1.22. What is the ratio of the CO2 emissions (% of total fuel combustion) in Slovak Republic in 2004 to that in 2007?
Keep it short and to the point. 0.96. What is the ratio of the CO2 emissions (% of total fuel combustion) of Canada in 2005 to that in 2006?
Provide a short and direct response. 1.06. What is the ratio of the CO2 emissions (% of total fuel combustion) in Croatia in 2005 to that in 2006?
Provide a short and direct response. 1.08. What is the ratio of the CO2 emissions (% of total fuel combustion) of Haiti in 2005 to that in 2006?
Offer a very short reply. 0.99. What is the ratio of the CO2 emissions (% of total fuel combustion) in Slovak Republic in 2005 to that in 2006?
Offer a terse response. 0.97. What is the ratio of the CO2 emissions (% of total fuel combustion) of Canada in 2005 to that in 2007?
Offer a very short reply. 1.08. What is the ratio of the CO2 emissions (% of total fuel combustion) in Croatia in 2005 to that in 2007?
Your response must be concise. 1.28. What is the ratio of the CO2 emissions (% of total fuel combustion) of Haiti in 2005 to that in 2007?
Give a very brief answer. 1.31. What is the ratio of the CO2 emissions (% of total fuel combustion) in Slovak Republic in 2005 to that in 2007?
Your answer should be compact. 1.02. What is the ratio of the CO2 emissions (% of total fuel combustion) in Canada in 2006 to that in 2007?
Keep it short and to the point. 1.01. What is the ratio of the CO2 emissions (% of total fuel combustion) of Croatia in 2006 to that in 2007?
Offer a very short reply. 1.18. What is the ratio of the CO2 emissions (% of total fuel combustion) of Haiti in 2006 to that in 2007?
Offer a terse response. 1.33. What is the ratio of the CO2 emissions (% of total fuel combustion) of Slovak Republic in 2006 to that in 2007?
Provide a succinct answer. 1.06. What is the difference between the highest and the second highest CO2 emissions (% of total fuel combustion) in Canada?
Keep it short and to the point. 0.06. What is the difference between the highest and the second highest CO2 emissions (% of total fuel combustion) in Croatia?
Make the answer very short. 0.23. What is the difference between the highest and the second highest CO2 emissions (% of total fuel combustion) of Haiti?
Your answer should be very brief. 3.55. What is the difference between the highest and the second highest CO2 emissions (% of total fuel combustion) in Slovak Republic?
Provide a succinct answer. 0.53. What is the difference between the highest and the lowest CO2 emissions (% of total fuel combustion) in Canada?
Give a very brief answer. 2.16. What is the difference between the highest and the lowest CO2 emissions (% of total fuel combustion) in Croatia?
Give a very brief answer. 3.5. What is the difference between the highest and the lowest CO2 emissions (% of total fuel combustion) in Haiti?
Give a very brief answer. 7.79. What is the difference between the highest and the lowest CO2 emissions (% of total fuel combustion) in Slovak Republic?
Keep it short and to the point. 2.92. 